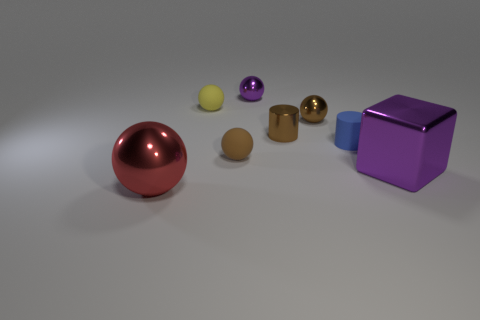Add 1 large blue cubes. How many objects exist? 9 Subtract all brown matte balls. How many balls are left? 4 Subtract all cubes. How many objects are left? 7 Subtract 1 cubes. How many cubes are left? 0 Subtract all blue cylinders. How many cylinders are left? 1 Subtract all yellow cylinders. Subtract all brown balls. How many cylinders are left? 2 Subtract all red blocks. How many blue cylinders are left? 1 Subtract all purple metal objects. Subtract all yellow rubber balls. How many objects are left? 5 Add 8 big spheres. How many big spheres are left? 9 Add 2 tiny metal cylinders. How many tiny metal cylinders exist? 3 